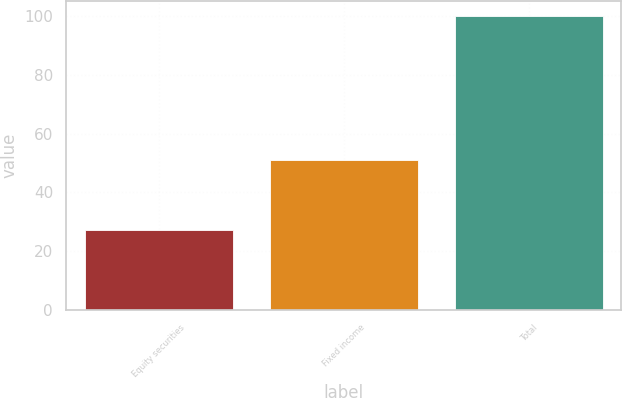Convert chart. <chart><loc_0><loc_0><loc_500><loc_500><bar_chart><fcel>Equity securities<fcel>Fixed income<fcel>Total<nl><fcel>27<fcel>51<fcel>100<nl></chart> 